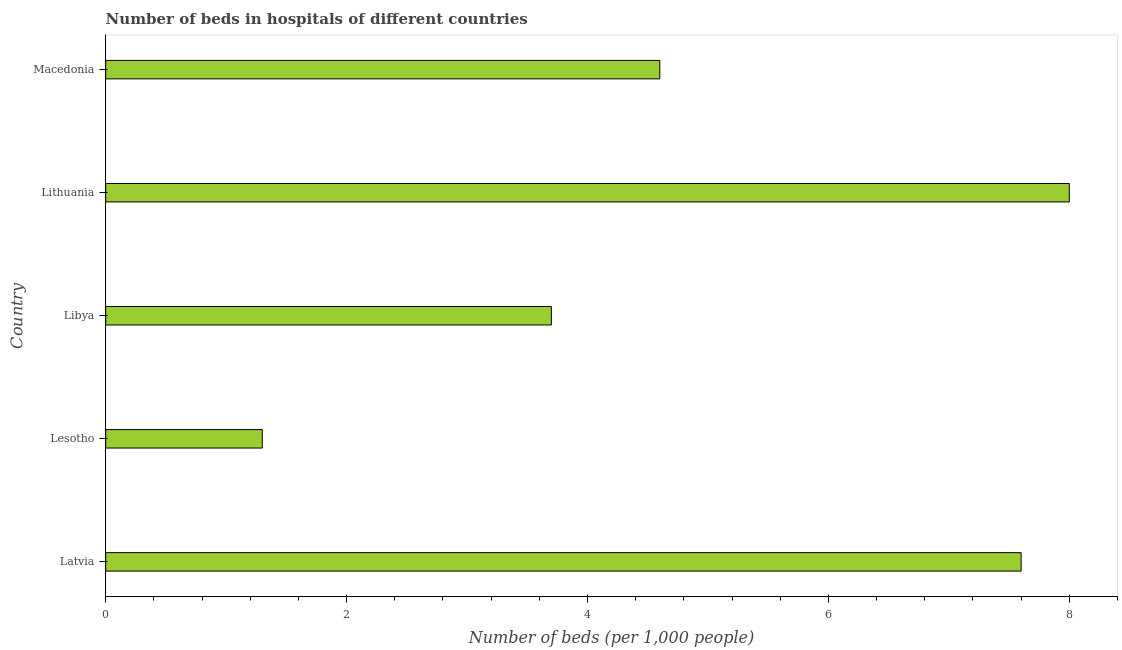Does the graph contain grids?
Give a very brief answer. No. What is the title of the graph?
Your response must be concise. Number of beds in hospitals of different countries. What is the label or title of the X-axis?
Your answer should be compact. Number of beds (per 1,0 people). Across all countries, what is the maximum number of hospital beds?
Offer a very short reply. 8. Across all countries, what is the minimum number of hospital beds?
Your answer should be very brief. 1.3. In which country was the number of hospital beds maximum?
Provide a short and direct response. Lithuania. In which country was the number of hospital beds minimum?
Keep it short and to the point. Lesotho. What is the sum of the number of hospital beds?
Your response must be concise. 25.2. What is the average number of hospital beds per country?
Ensure brevity in your answer.  5.04. In how many countries, is the number of hospital beds greater than 4.8 %?
Ensure brevity in your answer.  2. What is the ratio of the number of hospital beds in Lesotho to that in Libya?
Provide a succinct answer. 0.35. Is the difference between the number of hospital beds in Lesotho and Macedonia greater than the difference between any two countries?
Keep it short and to the point. No. What is the difference between the highest and the second highest number of hospital beds?
Ensure brevity in your answer.  0.4. Is the sum of the number of hospital beds in Latvia and Lithuania greater than the maximum number of hospital beds across all countries?
Your answer should be compact. Yes. What is the difference between two consecutive major ticks on the X-axis?
Give a very brief answer. 2. What is the Number of beds (per 1,000 people) of Latvia?
Keep it short and to the point. 7.6. What is the Number of beds (per 1,000 people) in Lesotho?
Offer a very short reply. 1.3. What is the Number of beds (per 1,000 people) in Lithuania?
Provide a succinct answer. 8. What is the difference between the Number of beds (per 1,000 people) in Latvia and Libya?
Give a very brief answer. 3.9. What is the difference between the Number of beds (per 1,000 people) in Latvia and Lithuania?
Provide a succinct answer. -0.4. What is the difference between the Number of beds (per 1,000 people) in Lesotho and Macedonia?
Your answer should be compact. -3.3. What is the difference between the Number of beds (per 1,000 people) in Libya and Lithuania?
Ensure brevity in your answer.  -4.3. What is the difference between the Number of beds (per 1,000 people) in Libya and Macedonia?
Your answer should be compact. -0.9. What is the difference between the Number of beds (per 1,000 people) in Lithuania and Macedonia?
Give a very brief answer. 3.4. What is the ratio of the Number of beds (per 1,000 people) in Latvia to that in Lesotho?
Offer a very short reply. 5.85. What is the ratio of the Number of beds (per 1,000 people) in Latvia to that in Libya?
Provide a short and direct response. 2.05. What is the ratio of the Number of beds (per 1,000 people) in Latvia to that in Lithuania?
Your answer should be very brief. 0.95. What is the ratio of the Number of beds (per 1,000 people) in Latvia to that in Macedonia?
Provide a succinct answer. 1.65. What is the ratio of the Number of beds (per 1,000 people) in Lesotho to that in Libya?
Give a very brief answer. 0.35. What is the ratio of the Number of beds (per 1,000 people) in Lesotho to that in Lithuania?
Make the answer very short. 0.16. What is the ratio of the Number of beds (per 1,000 people) in Lesotho to that in Macedonia?
Ensure brevity in your answer.  0.28. What is the ratio of the Number of beds (per 1,000 people) in Libya to that in Lithuania?
Ensure brevity in your answer.  0.46. What is the ratio of the Number of beds (per 1,000 people) in Libya to that in Macedonia?
Your answer should be very brief. 0.8. What is the ratio of the Number of beds (per 1,000 people) in Lithuania to that in Macedonia?
Give a very brief answer. 1.74. 